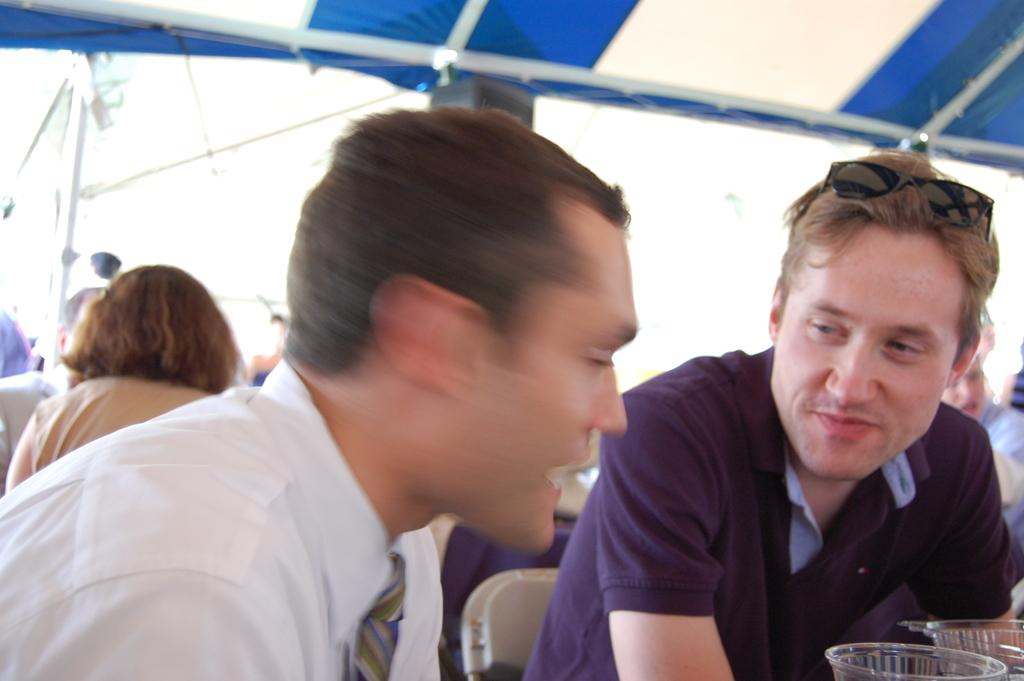What are the people in the image wearing? The persons in the image are wearing clothes. What can be seen in the bottom right corner of the image? There are glasses in the bottom right of the image. What structure is located at the top of the image? There is a tent at the top of the image. What type of joke is being told by the person wearing the hat in the image? There is no person wearing a hat in the image, nor is there any indication of a joke being told. 